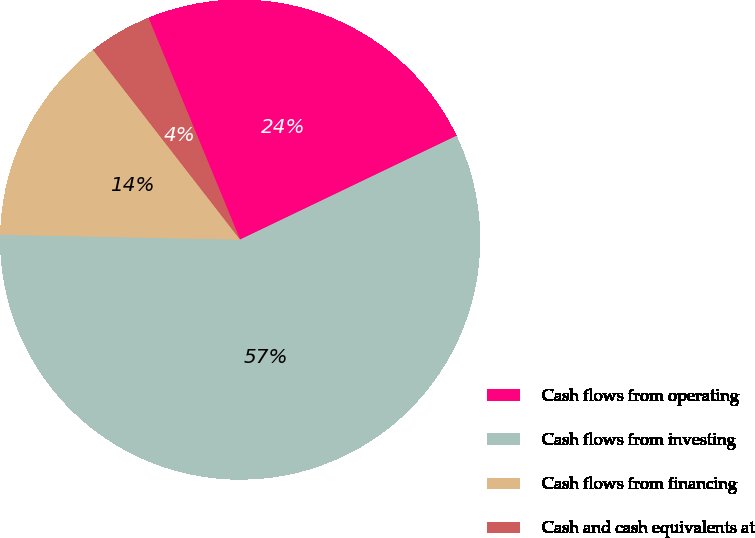Convert chart to OTSL. <chart><loc_0><loc_0><loc_500><loc_500><pie_chart><fcel>Cash flows from operating<fcel>Cash flows from investing<fcel>Cash flows from financing<fcel>Cash and cash equivalents at<nl><fcel>24.12%<fcel>57.44%<fcel>14.18%<fcel>4.26%<nl></chart> 